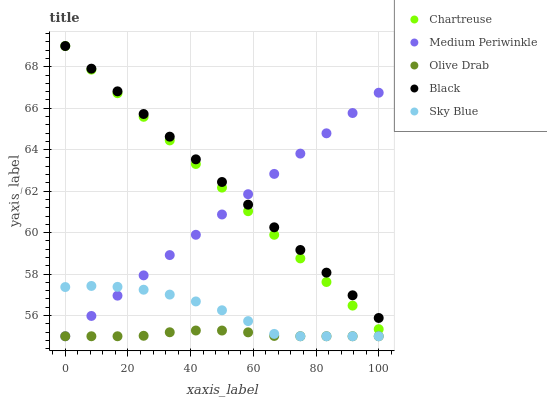Does Olive Drab have the minimum area under the curve?
Answer yes or no. Yes. Does Black have the maximum area under the curve?
Answer yes or no. Yes. Does Chartreuse have the minimum area under the curve?
Answer yes or no. No. Does Chartreuse have the maximum area under the curve?
Answer yes or no. No. Is Medium Periwinkle the smoothest?
Answer yes or no. Yes. Is Sky Blue the roughest?
Answer yes or no. Yes. Is Chartreuse the smoothest?
Answer yes or no. No. Is Chartreuse the roughest?
Answer yes or no. No. Does Medium Periwinkle have the lowest value?
Answer yes or no. Yes. Does Chartreuse have the lowest value?
Answer yes or no. No. Does Chartreuse have the highest value?
Answer yes or no. Yes. Does Medium Periwinkle have the highest value?
Answer yes or no. No. Is Olive Drab less than Black?
Answer yes or no. Yes. Is Black greater than Sky Blue?
Answer yes or no. Yes. Does Chartreuse intersect Black?
Answer yes or no. Yes. Is Chartreuse less than Black?
Answer yes or no. No. Is Chartreuse greater than Black?
Answer yes or no. No. Does Olive Drab intersect Black?
Answer yes or no. No. 